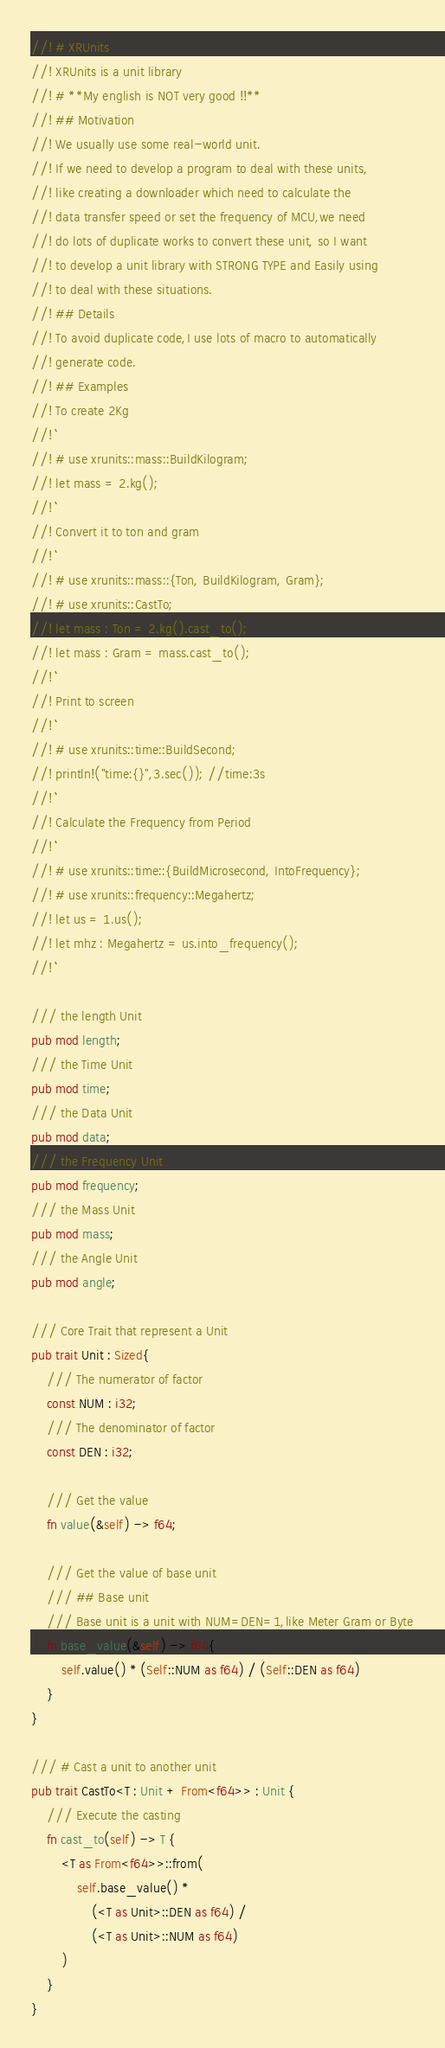<code> <loc_0><loc_0><loc_500><loc_500><_Rust_>//! # XRUnits
//! XRUnits is a unit library
//! # **My english is NOT very good !!**
//! ## Motivation
//! We usually use some real-world unit.
//! If we need to develop a program to deal with these units,
//! like creating a downloader which need to calculate the
//! data transfer speed or set the frequency of MCU,we need
//! do lots of duplicate works to convert these unit, so I want
//! to develop a unit library with STRONG TYPE and Easily using
//! to deal with these situations.
//! ## Details
//! To avoid duplicate code,I use lots of macro to automatically
//! generate code.
//! ## Examples
//! To create 2Kg
//! ```
//! # use xrunits::mass::BuildKilogram;
//! let mass = 2.kg();
//! ```
//! Convert it to ton and gram
//! ```
//! # use xrunits::mass::{Ton, BuildKilogram, Gram};
//! # use xrunits::CastTo;
//! let mass : Ton = 2.kg().cast_to();
//! let mass : Gram = mass.cast_to();
//! ```
//! Print to screen
//! ```
//! # use xrunits::time::BuildSecond;
//! println!("time:{}",3.sec()); //time:3s
//! ```
//! Calculate the Frequency from Period
//! ```
//! # use xrunits::time::{BuildMicrosecond, IntoFrequency};
//! # use xrunits::frequency::Megahertz;
//! let us = 1.us();
//! let mhz : Megahertz = us.into_frequency();
//! ```

/// the length Unit
pub mod length;
/// the Time Unit
pub mod time;
/// the Data Unit
pub mod data;
/// the Frequency Unit
pub mod frequency;
/// the Mass Unit
pub mod mass;
/// the Angle Unit
pub mod angle;

/// Core Trait that represent a Unit
pub trait Unit : Sized{
    /// The numerator of factor
    const NUM : i32;
    /// The denominator of factor
    const DEN : i32;

    /// Get the value
    fn value(&self) -> f64;

    /// Get the value of base unit
    /// ## Base unit
    /// Base unit is a unit with NUM=DEN=1,like Meter Gram or Byte
    fn base_value(&self) -> f64{
        self.value() * (Self::NUM as f64) / (Self::DEN as f64)
    }
}

/// # Cast a unit to another unit
pub trait CastTo<T : Unit + From<f64>> : Unit {
    /// Execute the casting
    fn cast_to(self) -> T {
        <T as From<f64>>::from(
            self.base_value() *
                (<T as Unit>::DEN as f64) /
                (<T as Unit>::NUM as f64)
        )
    }
}
</code> 